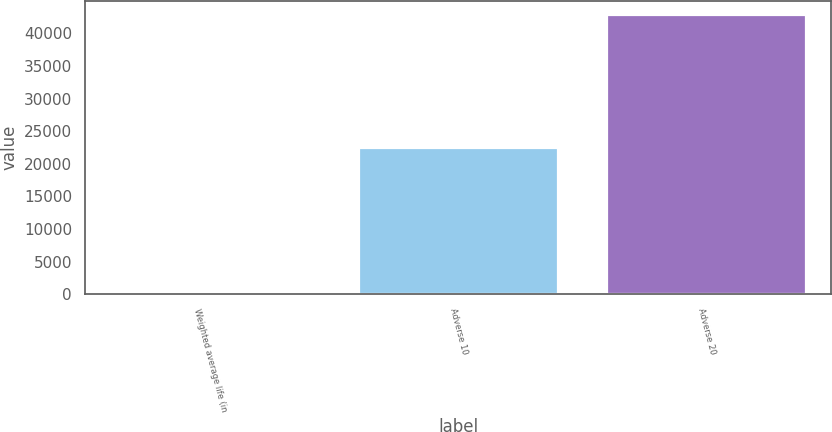Convert chart. <chart><loc_0><loc_0><loc_500><loc_500><bar_chart><fcel>Weighted average life (in<fcel>Adverse 10<fcel>Adverse 20<nl><fcel>1.4<fcel>22410<fcel>42796<nl></chart> 